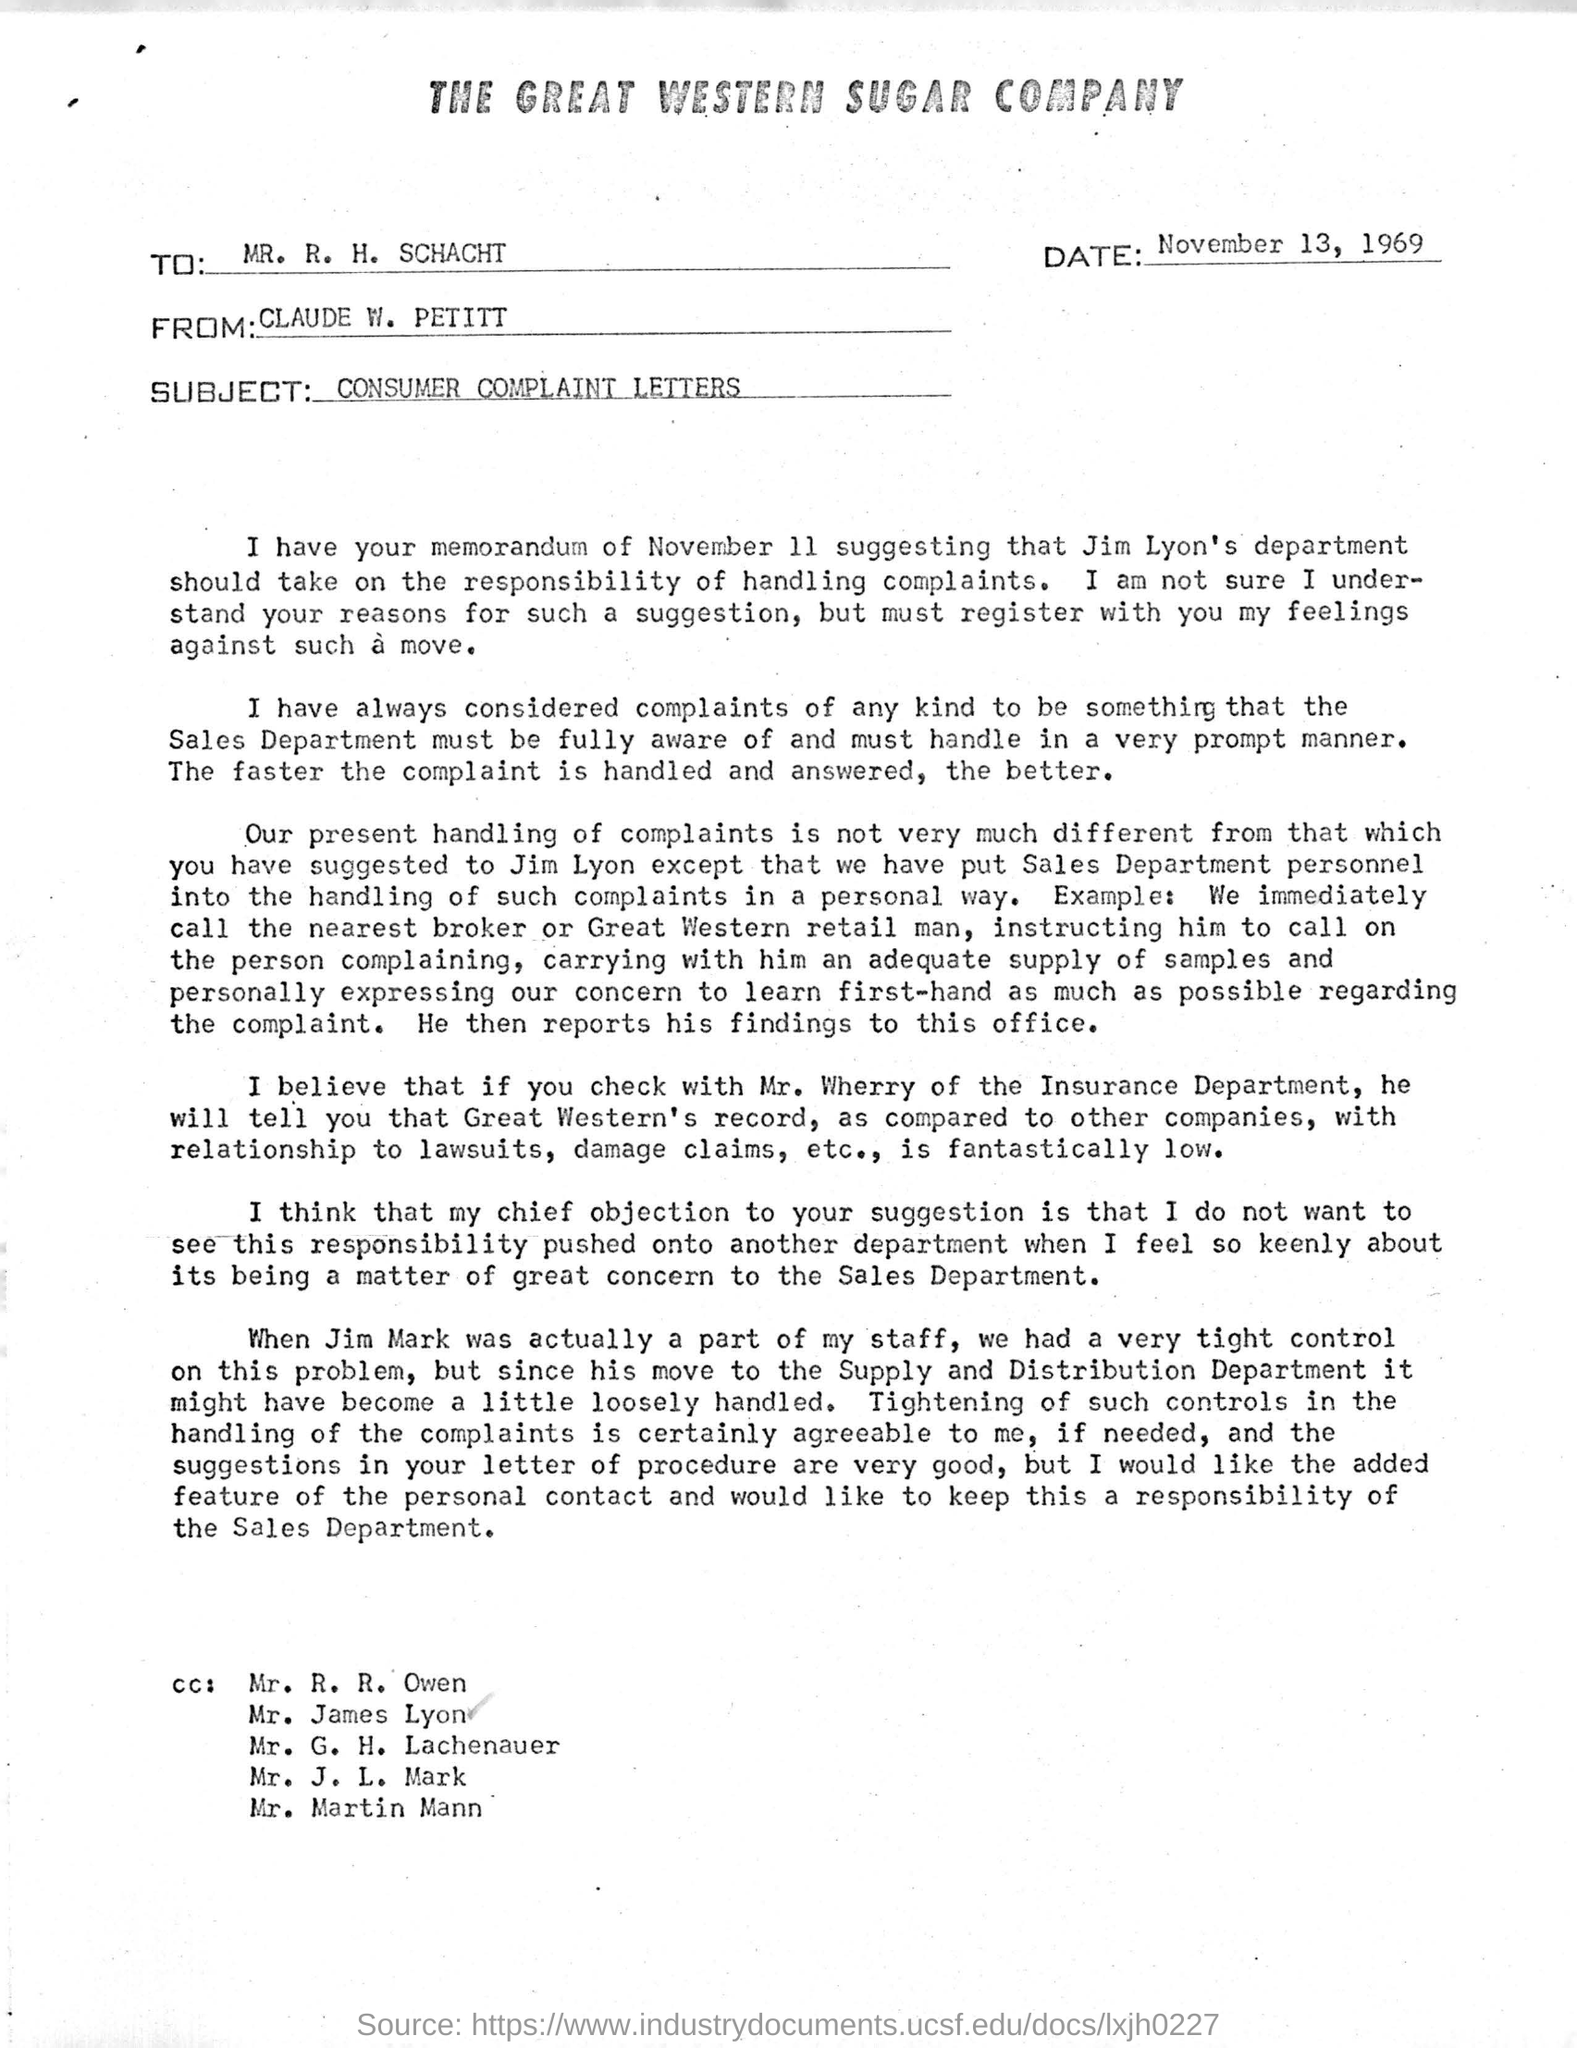What is the heading of the document?
Give a very brief answer. The Great Western Sugar Company. What is the date mentioned?
Give a very brief answer. November 13, 1969. Is the subject of this email?
Provide a succinct answer. CONSUMER COMPLAINT LETTERS. 